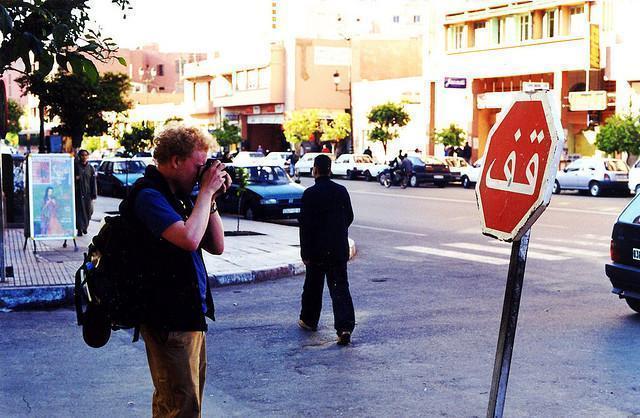What country is this?
Indicate the correct response and explain using: 'Answer: answer
Rationale: rationale.'
Options: India, canada, ireland, mexico. Answer: india.
Rationale: The writing on the sign is in the language of the country. 